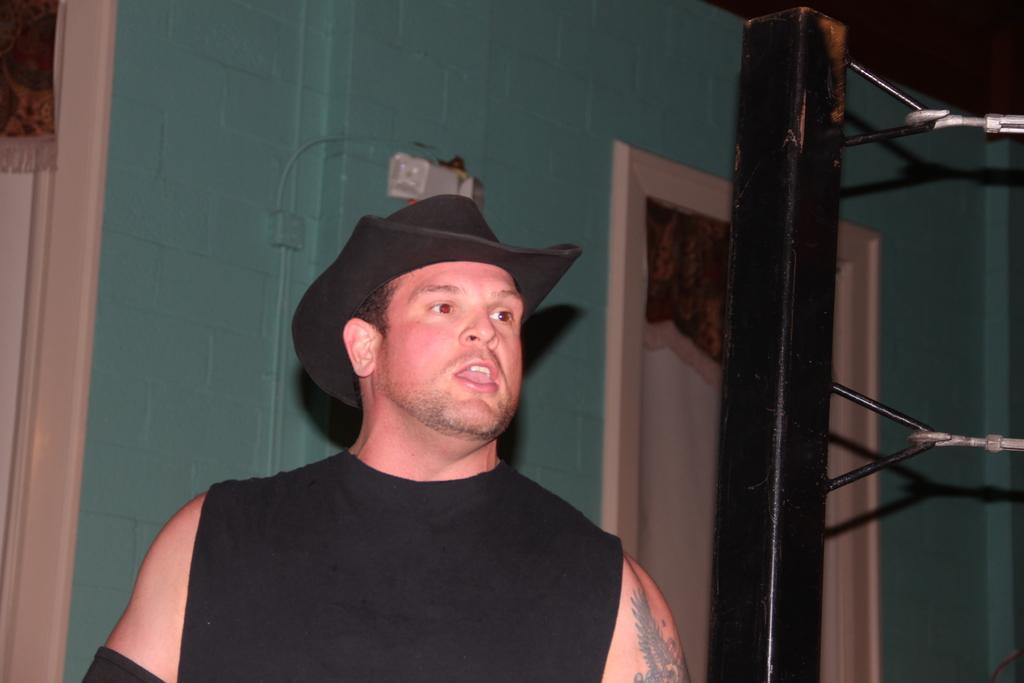Who is present in the image? There is a man in the image. What is the man wearing on his head? The man is wearing a black color hat. What color is the top that the man is wearing? The man is wearing a black color top. What can be seen in the background of the image? There is a wall and a wooden pole in the background of the image, along with other objects. How many fingers does the man have on his left hand in the image? The image does not show the man's fingers, so it is not possible to determine the number of fingers on his left hand. 